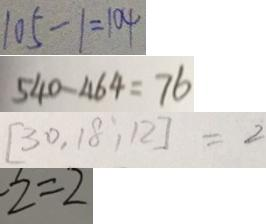Convert formula to latex. <formula><loc_0><loc_0><loc_500><loc_500>1 0 5 - 1 = 1 0 4 
 5 4 0 - 4 6 4 = 7 6 
 [ 3 0 , 1 8 , 1 2 ] = 2 
 - 2 = 2</formula> 